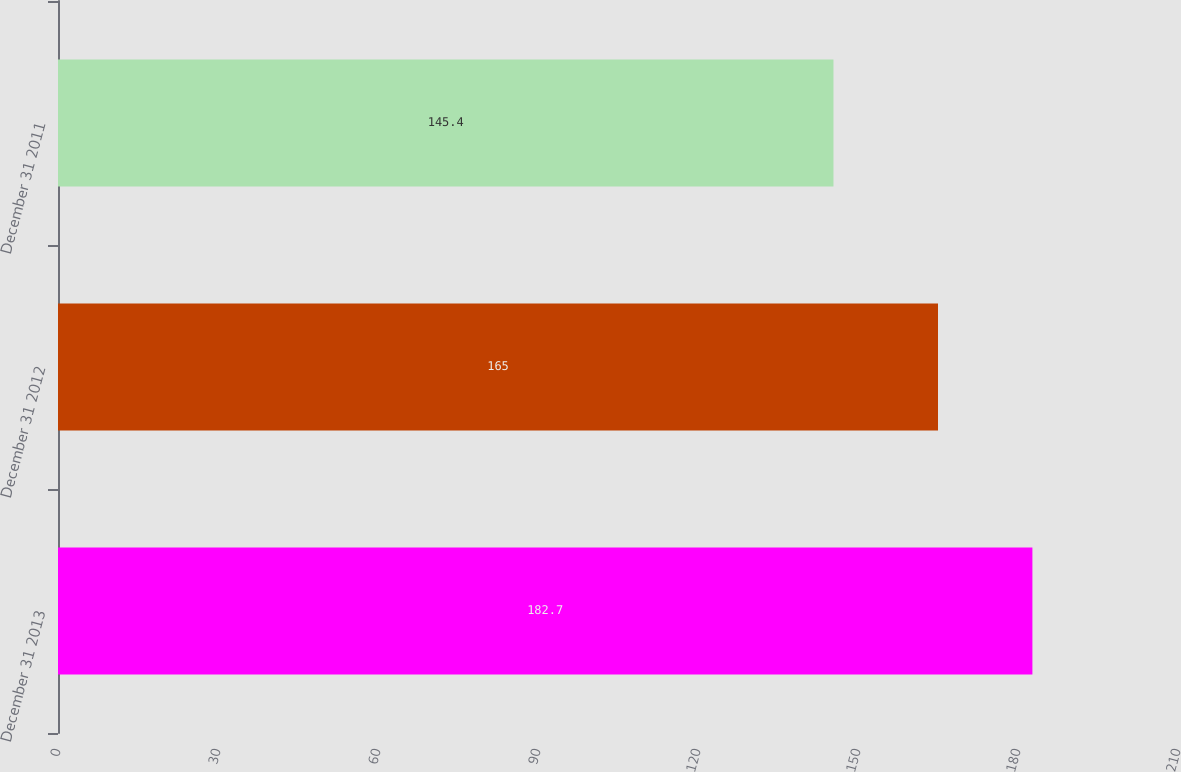Convert chart. <chart><loc_0><loc_0><loc_500><loc_500><bar_chart><fcel>December 31 2013<fcel>December 31 2012<fcel>December 31 2011<nl><fcel>182.7<fcel>165<fcel>145.4<nl></chart> 